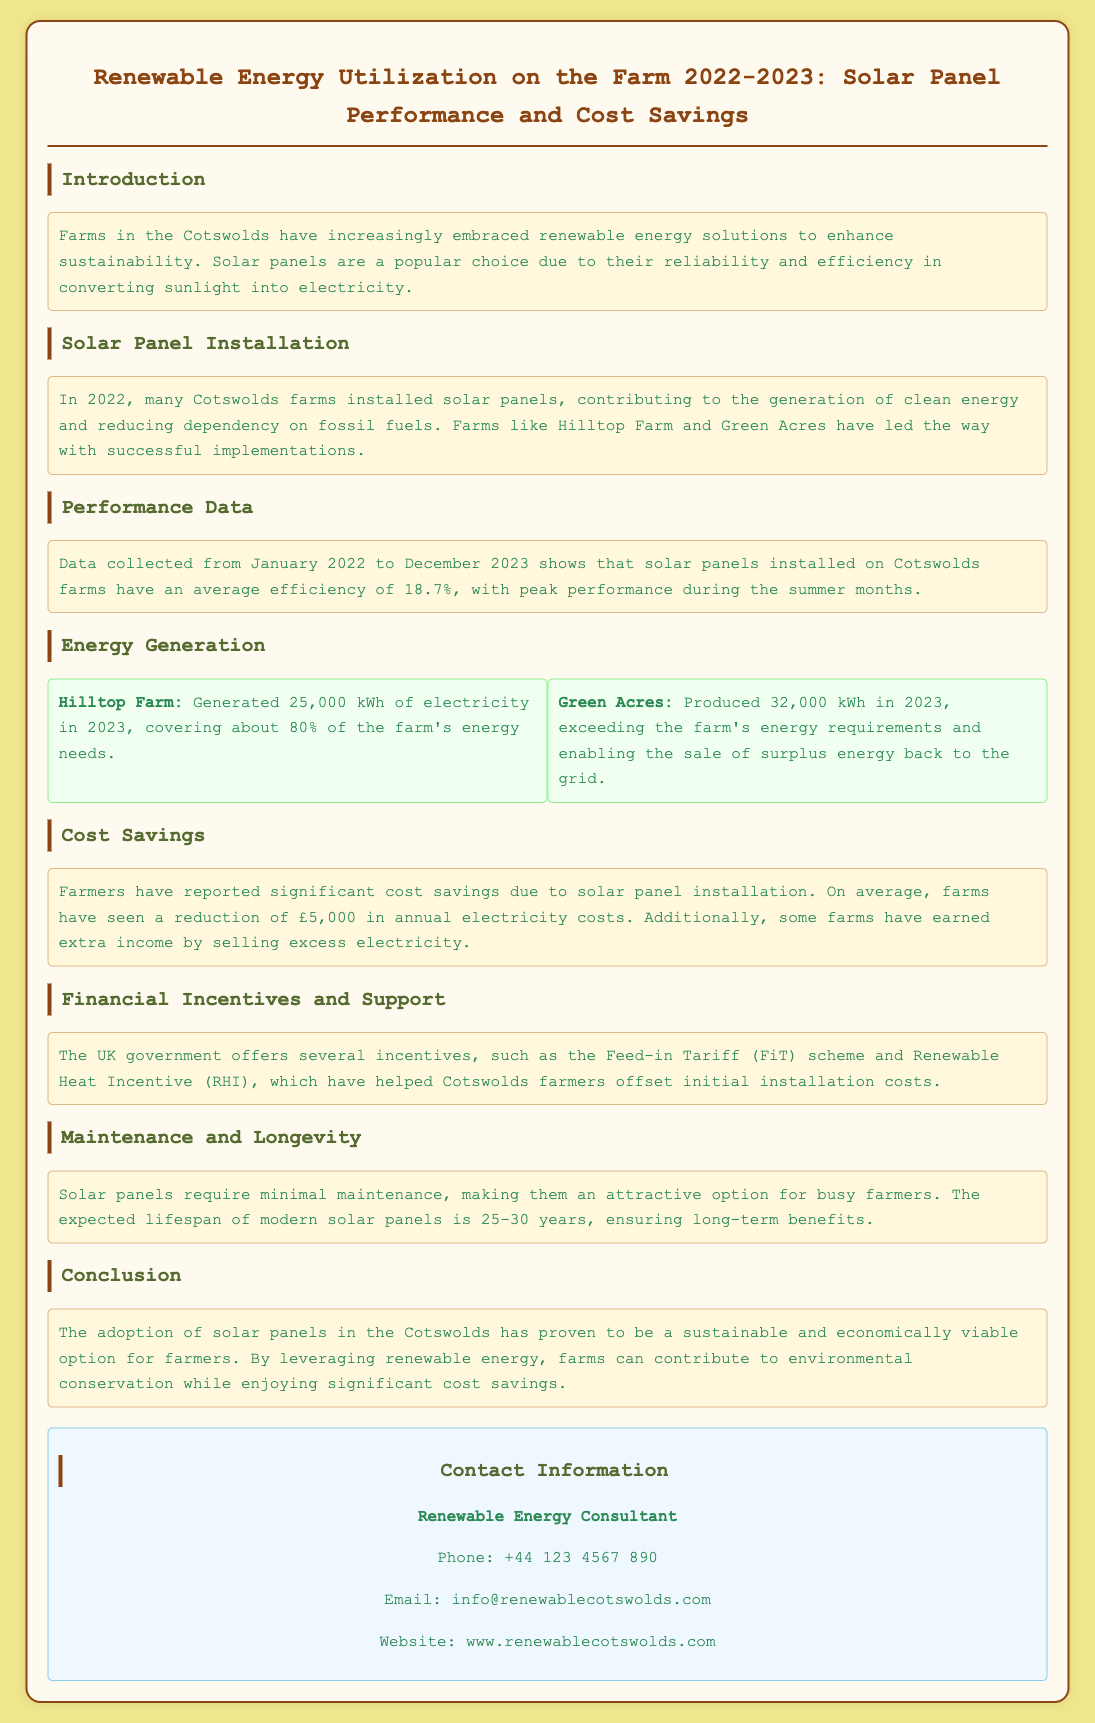What is the average efficiency of solar panels? The document states that the average efficiency of solar panels installed on Cotswolds farms is 18.7%.
Answer: 18.7% How much electricity did Hilltop Farm generate in 2023? Hilltop Farm generated 25,000 kWh of electricity in 2023.
Answer: 25,000 kWh What percentage of energy needs did Hilltop Farm cover with generated electricity? The document mentions that Hilltop Farm covered about 80% of its energy needs with generated electricity.
Answer: 80% How much cost reduction do farmers report due to solar panel installation? Farmers have reported a reduction of £5,000 in annual electricity costs due to solar panel installation.
Answer: £5,000 Which government scheme helps farmers offset installation costs? The document references the Feed-in Tariff (FiT) scheme as a government incentive that helps offset installation costs.
Answer: Feed-in Tariff (FiT) What is the expected lifespan of modern solar panels? The expected lifespan of modern solar panels is stated to be 25-30 years in the document.
Answer: 25-30 years Which farm exceeded its energy requirements and sold surplus energy? The document specifies that Green Acres exceeded its energy requirements and sold surplus energy back to the grid.
Answer: Green Acres What background color is used in the document? The document uses a background color of #f0e68c for the body.
Answer: #f0e68c What is the email contact for the Renewable Energy Consultant? The document provides info@renewablecotswolds.com as the email contact for the Renewable Energy Consultant.
Answer: info@renewablecotswolds.com 